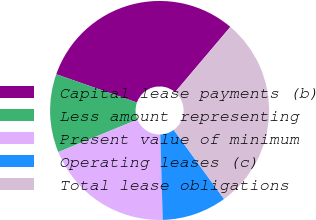<chart> <loc_0><loc_0><loc_500><loc_500><pie_chart><fcel>Capital lease payments (b)<fcel>Less amount representing<fcel>Present value of minimum<fcel>Operating leases (c)<fcel>Total lease obligations<nl><fcel>30.82%<fcel>11.57%<fcel>19.25%<fcel>9.56%<fcel>28.81%<nl></chart> 